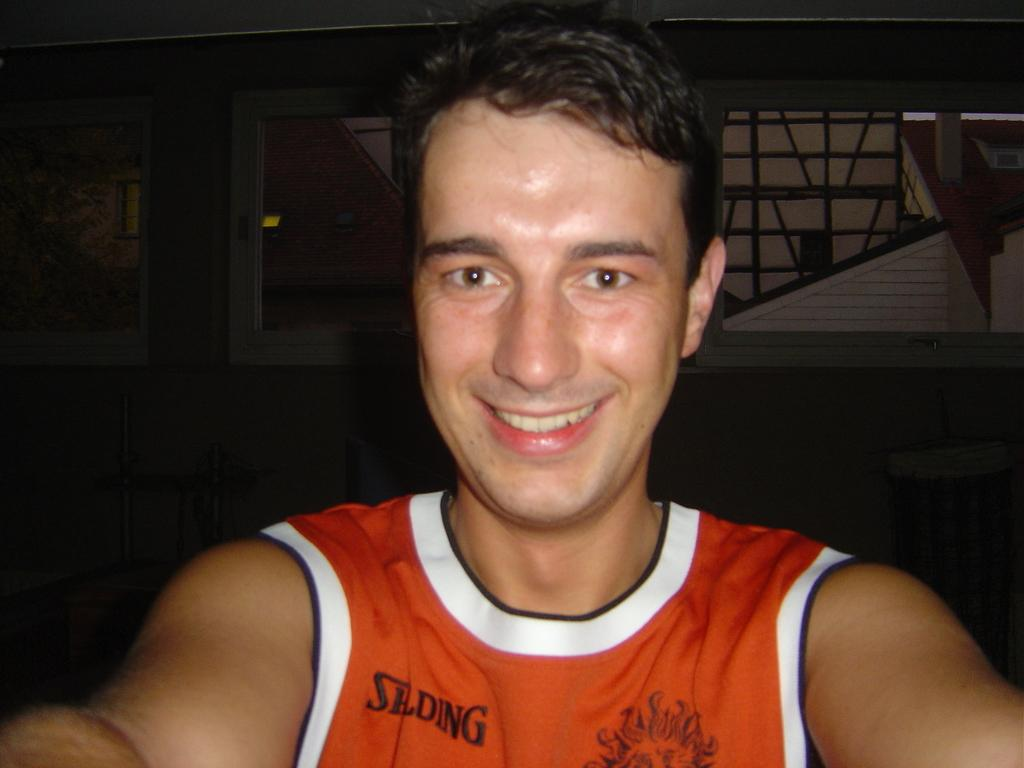<image>
Relay a brief, clear account of the picture shown. A man in an orange Spalding shirt smiles at the camera. 